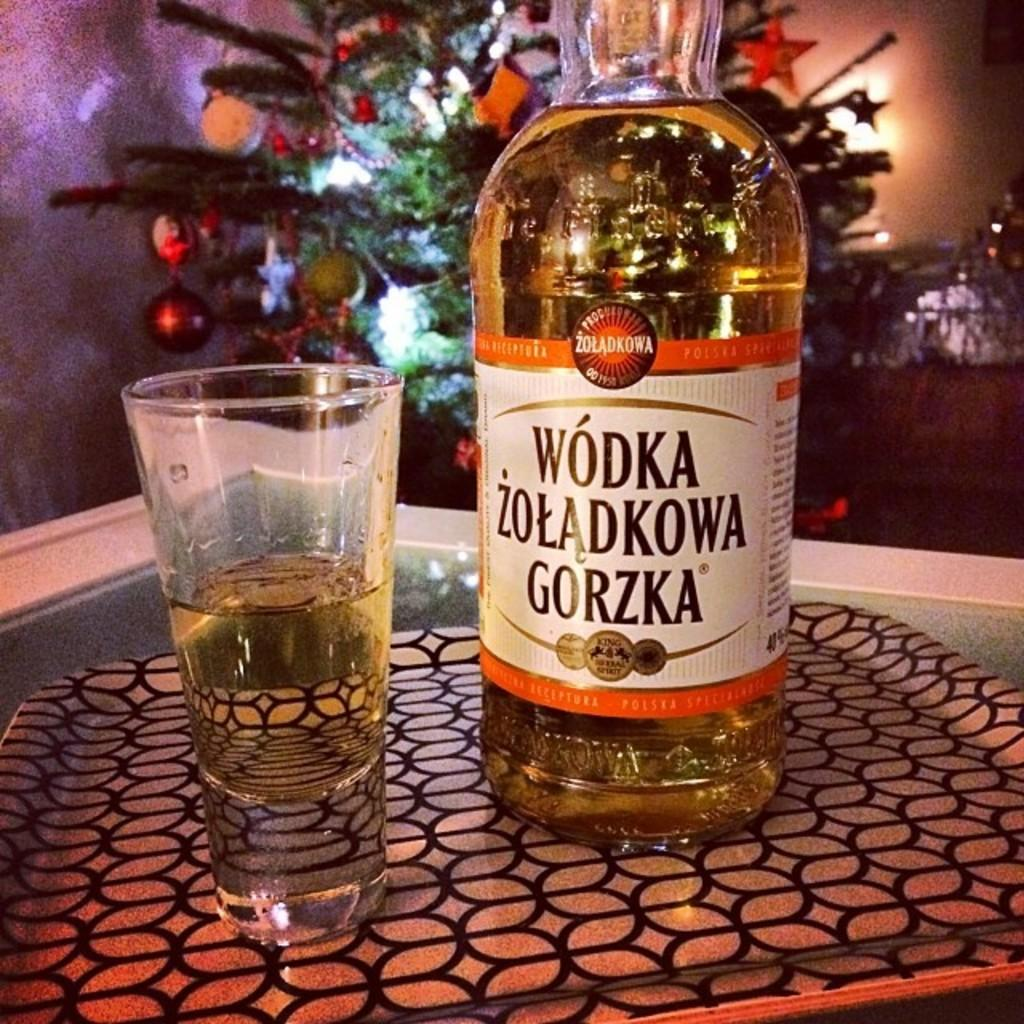What is on the table in the image? There is a glass and a bottle on the table in the image. What other object can be seen in the image? There is a tray in the image. What seasonal decoration is present in the image? There is a Christmas tree in the image. What type of background is visible in the image? There is a wall in the image. Where is the scarecrow hanging in the image? There is no scarecrow present in the image. What type of food is being served in the lunchroom in the image? There is no lunchroom present in the image. 